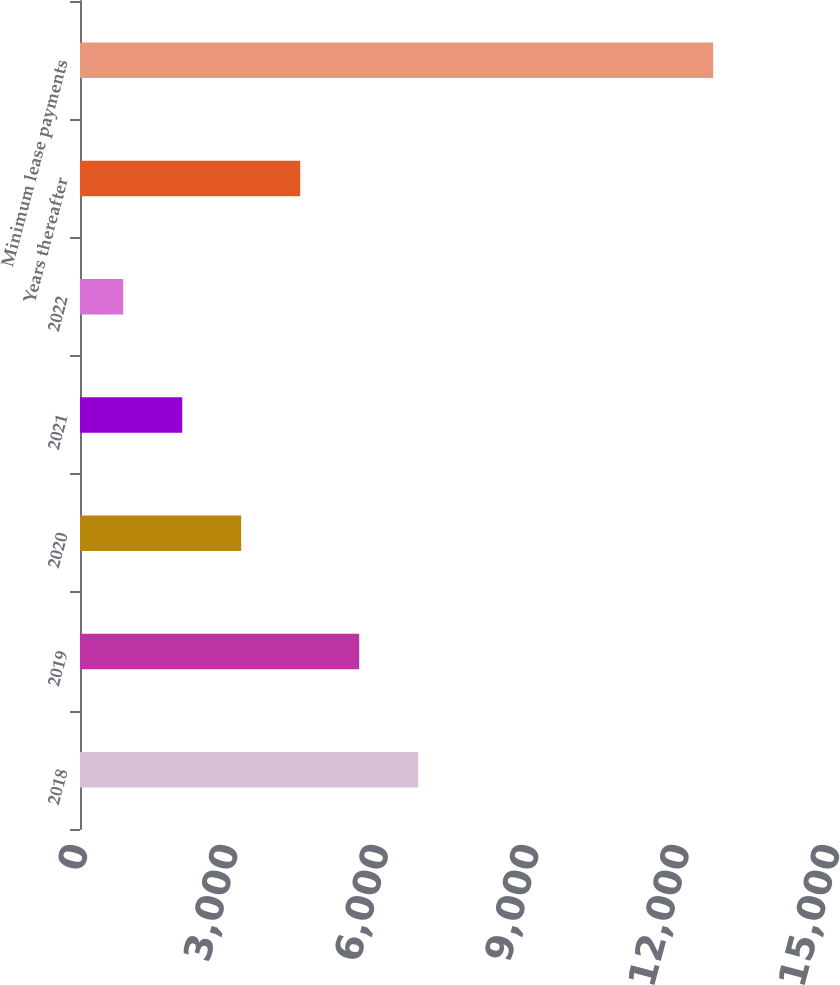<chart> <loc_0><loc_0><loc_500><loc_500><bar_chart><fcel>2018<fcel>2019<fcel>2020<fcel>2021<fcel>2022<fcel>Years thereafter<fcel>Minimum lease payments<nl><fcel>6746<fcel>5569.2<fcel>3215.6<fcel>2038.8<fcel>862<fcel>4392.4<fcel>12630<nl></chart> 